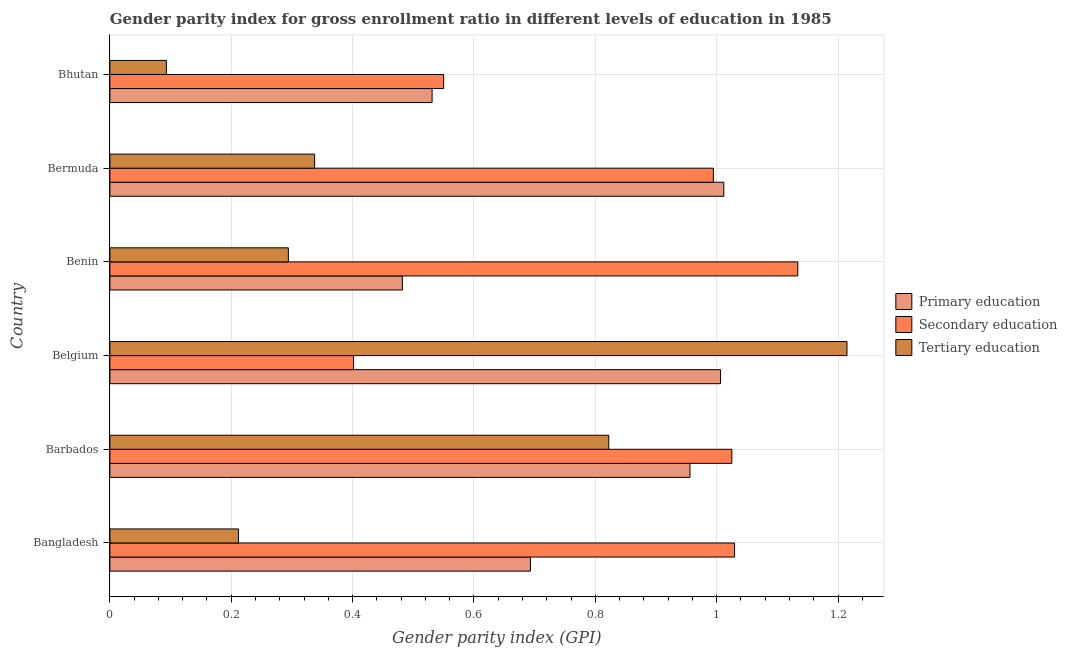Are the number of bars per tick equal to the number of legend labels?
Your answer should be very brief. Yes. Are the number of bars on each tick of the Y-axis equal?
Offer a terse response. Yes. How many bars are there on the 1st tick from the top?
Give a very brief answer. 3. How many bars are there on the 3rd tick from the bottom?
Your answer should be compact. 3. What is the label of the 1st group of bars from the top?
Offer a terse response. Bhutan. What is the gender parity index in tertiary education in Bhutan?
Ensure brevity in your answer.  0.09. Across all countries, what is the maximum gender parity index in primary education?
Your response must be concise. 1.01. Across all countries, what is the minimum gender parity index in primary education?
Your response must be concise. 0.48. In which country was the gender parity index in secondary education maximum?
Ensure brevity in your answer.  Benin. In which country was the gender parity index in tertiary education minimum?
Offer a very short reply. Bhutan. What is the total gender parity index in primary education in the graph?
Your answer should be very brief. 4.68. What is the difference between the gender parity index in tertiary education in Belgium and that in Benin?
Ensure brevity in your answer.  0.92. What is the difference between the gender parity index in tertiary education in Bangladesh and the gender parity index in secondary education in Bhutan?
Make the answer very short. -0.34. What is the average gender parity index in primary education per country?
Make the answer very short. 0.78. What is the difference between the gender parity index in secondary education and gender parity index in primary education in Bangladesh?
Ensure brevity in your answer.  0.34. What is the ratio of the gender parity index in secondary education in Bangladesh to that in Bhutan?
Provide a succinct answer. 1.87. Is the gender parity index in secondary education in Bangladesh less than that in Benin?
Give a very brief answer. Yes. Is the difference between the gender parity index in secondary education in Benin and Bermuda greater than the difference between the gender parity index in tertiary education in Benin and Bermuda?
Provide a succinct answer. Yes. What is the difference between the highest and the second highest gender parity index in tertiary education?
Your answer should be compact. 0.39. What is the difference between the highest and the lowest gender parity index in secondary education?
Make the answer very short. 0.73. In how many countries, is the gender parity index in primary education greater than the average gender parity index in primary education taken over all countries?
Your response must be concise. 3. What does the 2nd bar from the top in Bermuda represents?
Provide a short and direct response. Secondary education. What does the 3rd bar from the bottom in Bangladesh represents?
Keep it short and to the point. Tertiary education. Is it the case that in every country, the sum of the gender parity index in primary education and gender parity index in secondary education is greater than the gender parity index in tertiary education?
Give a very brief answer. Yes. How many bars are there?
Your response must be concise. 18. Are the values on the major ticks of X-axis written in scientific E-notation?
Your answer should be very brief. No. Does the graph contain any zero values?
Keep it short and to the point. No. What is the title of the graph?
Offer a terse response. Gender parity index for gross enrollment ratio in different levels of education in 1985. Does "Taxes on international trade" appear as one of the legend labels in the graph?
Give a very brief answer. No. What is the label or title of the X-axis?
Make the answer very short. Gender parity index (GPI). What is the label or title of the Y-axis?
Provide a succinct answer. Country. What is the Gender parity index (GPI) of Primary education in Bangladesh?
Provide a succinct answer. 0.69. What is the Gender parity index (GPI) in Secondary education in Bangladesh?
Your response must be concise. 1.03. What is the Gender parity index (GPI) in Tertiary education in Bangladesh?
Your answer should be compact. 0.21. What is the Gender parity index (GPI) of Primary education in Barbados?
Your answer should be very brief. 0.96. What is the Gender parity index (GPI) in Secondary education in Barbados?
Give a very brief answer. 1.02. What is the Gender parity index (GPI) of Tertiary education in Barbados?
Your answer should be very brief. 0.82. What is the Gender parity index (GPI) in Primary education in Belgium?
Offer a very short reply. 1.01. What is the Gender parity index (GPI) in Secondary education in Belgium?
Provide a succinct answer. 0.4. What is the Gender parity index (GPI) of Tertiary education in Belgium?
Offer a very short reply. 1.21. What is the Gender parity index (GPI) of Primary education in Benin?
Provide a short and direct response. 0.48. What is the Gender parity index (GPI) in Secondary education in Benin?
Your answer should be very brief. 1.13. What is the Gender parity index (GPI) in Tertiary education in Benin?
Provide a short and direct response. 0.29. What is the Gender parity index (GPI) in Primary education in Bermuda?
Your response must be concise. 1.01. What is the Gender parity index (GPI) in Secondary education in Bermuda?
Offer a terse response. 0.99. What is the Gender parity index (GPI) in Tertiary education in Bermuda?
Ensure brevity in your answer.  0.34. What is the Gender parity index (GPI) of Primary education in Bhutan?
Provide a short and direct response. 0.53. What is the Gender parity index (GPI) of Secondary education in Bhutan?
Provide a short and direct response. 0.55. What is the Gender parity index (GPI) in Tertiary education in Bhutan?
Offer a very short reply. 0.09. Across all countries, what is the maximum Gender parity index (GPI) in Primary education?
Offer a terse response. 1.01. Across all countries, what is the maximum Gender parity index (GPI) in Secondary education?
Your answer should be very brief. 1.13. Across all countries, what is the maximum Gender parity index (GPI) in Tertiary education?
Ensure brevity in your answer.  1.21. Across all countries, what is the minimum Gender parity index (GPI) of Primary education?
Give a very brief answer. 0.48. Across all countries, what is the minimum Gender parity index (GPI) in Secondary education?
Keep it short and to the point. 0.4. Across all countries, what is the minimum Gender parity index (GPI) in Tertiary education?
Give a very brief answer. 0.09. What is the total Gender parity index (GPI) of Primary education in the graph?
Keep it short and to the point. 4.68. What is the total Gender parity index (GPI) in Secondary education in the graph?
Offer a terse response. 5.13. What is the total Gender parity index (GPI) in Tertiary education in the graph?
Provide a succinct answer. 2.97. What is the difference between the Gender parity index (GPI) in Primary education in Bangladesh and that in Barbados?
Offer a very short reply. -0.26. What is the difference between the Gender parity index (GPI) in Secondary education in Bangladesh and that in Barbados?
Provide a succinct answer. 0. What is the difference between the Gender parity index (GPI) of Tertiary education in Bangladesh and that in Barbados?
Provide a succinct answer. -0.61. What is the difference between the Gender parity index (GPI) in Primary education in Bangladesh and that in Belgium?
Your answer should be very brief. -0.31. What is the difference between the Gender parity index (GPI) in Secondary education in Bangladesh and that in Belgium?
Ensure brevity in your answer.  0.63. What is the difference between the Gender parity index (GPI) of Tertiary education in Bangladesh and that in Belgium?
Your answer should be compact. -1. What is the difference between the Gender parity index (GPI) in Primary education in Bangladesh and that in Benin?
Make the answer very short. 0.21. What is the difference between the Gender parity index (GPI) in Secondary education in Bangladesh and that in Benin?
Offer a terse response. -0.1. What is the difference between the Gender parity index (GPI) of Tertiary education in Bangladesh and that in Benin?
Make the answer very short. -0.08. What is the difference between the Gender parity index (GPI) of Primary education in Bangladesh and that in Bermuda?
Provide a succinct answer. -0.32. What is the difference between the Gender parity index (GPI) in Secondary education in Bangladesh and that in Bermuda?
Provide a succinct answer. 0.03. What is the difference between the Gender parity index (GPI) in Tertiary education in Bangladesh and that in Bermuda?
Offer a very short reply. -0.13. What is the difference between the Gender parity index (GPI) of Primary education in Bangladesh and that in Bhutan?
Make the answer very short. 0.16. What is the difference between the Gender parity index (GPI) in Secondary education in Bangladesh and that in Bhutan?
Offer a terse response. 0.48. What is the difference between the Gender parity index (GPI) in Tertiary education in Bangladesh and that in Bhutan?
Keep it short and to the point. 0.12. What is the difference between the Gender parity index (GPI) of Primary education in Barbados and that in Belgium?
Make the answer very short. -0.05. What is the difference between the Gender parity index (GPI) of Secondary education in Barbados and that in Belgium?
Ensure brevity in your answer.  0.62. What is the difference between the Gender parity index (GPI) of Tertiary education in Barbados and that in Belgium?
Provide a succinct answer. -0.39. What is the difference between the Gender parity index (GPI) of Primary education in Barbados and that in Benin?
Give a very brief answer. 0.47. What is the difference between the Gender parity index (GPI) of Secondary education in Barbados and that in Benin?
Make the answer very short. -0.11. What is the difference between the Gender parity index (GPI) in Tertiary education in Barbados and that in Benin?
Provide a short and direct response. 0.53. What is the difference between the Gender parity index (GPI) of Primary education in Barbados and that in Bermuda?
Ensure brevity in your answer.  -0.06. What is the difference between the Gender parity index (GPI) in Secondary education in Barbados and that in Bermuda?
Offer a terse response. 0.03. What is the difference between the Gender parity index (GPI) of Tertiary education in Barbados and that in Bermuda?
Your response must be concise. 0.48. What is the difference between the Gender parity index (GPI) in Primary education in Barbados and that in Bhutan?
Make the answer very short. 0.42. What is the difference between the Gender parity index (GPI) in Secondary education in Barbados and that in Bhutan?
Offer a terse response. 0.47. What is the difference between the Gender parity index (GPI) of Tertiary education in Barbados and that in Bhutan?
Give a very brief answer. 0.73. What is the difference between the Gender parity index (GPI) in Primary education in Belgium and that in Benin?
Your answer should be compact. 0.52. What is the difference between the Gender parity index (GPI) of Secondary education in Belgium and that in Benin?
Ensure brevity in your answer.  -0.73. What is the difference between the Gender parity index (GPI) of Tertiary education in Belgium and that in Benin?
Offer a terse response. 0.92. What is the difference between the Gender parity index (GPI) of Primary education in Belgium and that in Bermuda?
Offer a very short reply. -0.01. What is the difference between the Gender parity index (GPI) in Secondary education in Belgium and that in Bermuda?
Your answer should be very brief. -0.59. What is the difference between the Gender parity index (GPI) in Tertiary education in Belgium and that in Bermuda?
Your answer should be very brief. 0.88. What is the difference between the Gender parity index (GPI) in Primary education in Belgium and that in Bhutan?
Provide a short and direct response. 0.48. What is the difference between the Gender parity index (GPI) of Secondary education in Belgium and that in Bhutan?
Offer a terse response. -0.15. What is the difference between the Gender parity index (GPI) of Tertiary education in Belgium and that in Bhutan?
Your response must be concise. 1.12. What is the difference between the Gender parity index (GPI) of Primary education in Benin and that in Bermuda?
Give a very brief answer. -0.53. What is the difference between the Gender parity index (GPI) in Secondary education in Benin and that in Bermuda?
Your answer should be compact. 0.14. What is the difference between the Gender parity index (GPI) of Tertiary education in Benin and that in Bermuda?
Offer a terse response. -0.04. What is the difference between the Gender parity index (GPI) of Primary education in Benin and that in Bhutan?
Your answer should be very brief. -0.05. What is the difference between the Gender parity index (GPI) in Secondary education in Benin and that in Bhutan?
Your answer should be compact. 0.58. What is the difference between the Gender parity index (GPI) in Tertiary education in Benin and that in Bhutan?
Your answer should be compact. 0.2. What is the difference between the Gender parity index (GPI) in Primary education in Bermuda and that in Bhutan?
Your response must be concise. 0.48. What is the difference between the Gender parity index (GPI) of Secondary education in Bermuda and that in Bhutan?
Offer a terse response. 0.44. What is the difference between the Gender parity index (GPI) in Tertiary education in Bermuda and that in Bhutan?
Offer a very short reply. 0.24. What is the difference between the Gender parity index (GPI) in Primary education in Bangladesh and the Gender parity index (GPI) in Secondary education in Barbados?
Provide a succinct answer. -0.33. What is the difference between the Gender parity index (GPI) of Primary education in Bangladesh and the Gender parity index (GPI) of Tertiary education in Barbados?
Your answer should be very brief. -0.13. What is the difference between the Gender parity index (GPI) of Secondary education in Bangladesh and the Gender parity index (GPI) of Tertiary education in Barbados?
Make the answer very short. 0.21. What is the difference between the Gender parity index (GPI) in Primary education in Bangladesh and the Gender parity index (GPI) in Secondary education in Belgium?
Your answer should be very brief. 0.29. What is the difference between the Gender parity index (GPI) in Primary education in Bangladesh and the Gender parity index (GPI) in Tertiary education in Belgium?
Give a very brief answer. -0.52. What is the difference between the Gender parity index (GPI) in Secondary education in Bangladesh and the Gender parity index (GPI) in Tertiary education in Belgium?
Your answer should be compact. -0.19. What is the difference between the Gender parity index (GPI) of Primary education in Bangladesh and the Gender parity index (GPI) of Secondary education in Benin?
Your answer should be compact. -0.44. What is the difference between the Gender parity index (GPI) in Primary education in Bangladesh and the Gender parity index (GPI) in Tertiary education in Benin?
Ensure brevity in your answer.  0.4. What is the difference between the Gender parity index (GPI) in Secondary education in Bangladesh and the Gender parity index (GPI) in Tertiary education in Benin?
Make the answer very short. 0.74. What is the difference between the Gender parity index (GPI) in Primary education in Bangladesh and the Gender parity index (GPI) in Secondary education in Bermuda?
Give a very brief answer. -0.3. What is the difference between the Gender parity index (GPI) of Primary education in Bangladesh and the Gender parity index (GPI) of Tertiary education in Bermuda?
Your answer should be very brief. 0.36. What is the difference between the Gender parity index (GPI) of Secondary education in Bangladesh and the Gender parity index (GPI) of Tertiary education in Bermuda?
Keep it short and to the point. 0.69. What is the difference between the Gender parity index (GPI) in Primary education in Bangladesh and the Gender parity index (GPI) in Secondary education in Bhutan?
Your answer should be compact. 0.14. What is the difference between the Gender parity index (GPI) of Secondary education in Bangladesh and the Gender parity index (GPI) of Tertiary education in Bhutan?
Offer a very short reply. 0.94. What is the difference between the Gender parity index (GPI) in Primary education in Barbados and the Gender parity index (GPI) in Secondary education in Belgium?
Your response must be concise. 0.55. What is the difference between the Gender parity index (GPI) in Primary education in Barbados and the Gender parity index (GPI) in Tertiary education in Belgium?
Give a very brief answer. -0.26. What is the difference between the Gender parity index (GPI) in Secondary education in Barbados and the Gender parity index (GPI) in Tertiary education in Belgium?
Offer a very short reply. -0.19. What is the difference between the Gender parity index (GPI) in Primary education in Barbados and the Gender parity index (GPI) in Secondary education in Benin?
Make the answer very short. -0.18. What is the difference between the Gender parity index (GPI) of Primary education in Barbados and the Gender parity index (GPI) of Tertiary education in Benin?
Provide a succinct answer. 0.66. What is the difference between the Gender parity index (GPI) in Secondary education in Barbados and the Gender parity index (GPI) in Tertiary education in Benin?
Ensure brevity in your answer.  0.73. What is the difference between the Gender parity index (GPI) of Primary education in Barbados and the Gender parity index (GPI) of Secondary education in Bermuda?
Give a very brief answer. -0.04. What is the difference between the Gender parity index (GPI) in Primary education in Barbados and the Gender parity index (GPI) in Tertiary education in Bermuda?
Your answer should be very brief. 0.62. What is the difference between the Gender parity index (GPI) of Secondary education in Barbados and the Gender parity index (GPI) of Tertiary education in Bermuda?
Offer a very short reply. 0.69. What is the difference between the Gender parity index (GPI) in Primary education in Barbados and the Gender parity index (GPI) in Secondary education in Bhutan?
Your answer should be compact. 0.41. What is the difference between the Gender parity index (GPI) of Primary education in Barbados and the Gender parity index (GPI) of Tertiary education in Bhutan?
Make the answer very short. 0.86. What is the difference between the Gender parity index (GPI) of Secondary education in Barbados and the Gender parity index (GPI) of Tertiary education in Bhutan?
Keep it short and to the point. 0.93. What is the difference between the Gender parity index (GPI) of Primary education in Belgium and the Gender parity index (GPI) of Secondary education in Benin?
Your response must be concise. -0.13. What is the difference between the Gender parity index (GPI) of Primary education in Belgium and the Gender parity index (GPI) of Tertiary education in Benin?
Your response must be concise. 0.71. What is the difference between the Gender parity index (GPI) in Secondary education in Belgium and the Gender parity index (GPI) in Tertiary education in Benin?
Your answer should be compact. 0.11. What is the difference between the Gender parity index (GPI) of Primary education in Belgium and the Gender parity index (GPI) of Secondary education in Bermuda?
Provide a short and direct response. 0.01. What is the difference between the Gender parity index (GPI) in Primary education in Belgium and the Gender parity index (GPI) in Tertiary education in Bermuda?
Your answer should be very brief. 0.67. What is the difference between the Gender parity index (GPI) of Secondary education in Belgium and the Gender parity index (GPI) of Tertiary education in Bermuda?
Your response must be concise. 0.06. What is the difference between the Gender parity index (GPI) of Primary education in Belgium and the Gender parity index (GPI) of Secondary education in Bhutan?
Offer a terse response. 0.46. What is the difference between the Gender parity index (GPI) in Primary education in Belgium and the Gender parity index (GPI) in Tertiary education in Bhutan?
Ensure brevity in your answer.  0.91. What is the difference between the Gender parity index (GPI) in Secondary education in Belgium and the Gender parity index (GPI) in Tertiary education in Bhutan?
Your answer should be very brief. 0.31. What is the difference between the Gender parity index (GPI) in Primary education in Benin and the Gender parity index (GPI) in Secondary education in Bermuda?
Your answer should be compact. -0.51. What is the difference between the Gender parity index (GPI) in Primary education in Benin and the Gender parity index (GPI) in Tertiary education in Bermuda?
Make the answer very short. 0.14. What is the difference between the Gender parity index (GPI) of Secondary education in Benin and the Gender parity index (GPI) of Tertiary education in Bermuda?
Offer a very short reply. 0.8. What is the difference between the Gender parity index (GPI) of Primary education in Benin and the Gender parity index (GPI) of Secondary education in Bhutan?
Ensure brevity in your answer.  -0.07. What is the difference between the Gender parity index (GPI) of Primary education in Benin and the Gender parity index (GPI) of Tertiary education in Bhutan?
Your response must be concise. 0.39. What is the difference between the Gender parity index (GPI) in Secondary education in Benin and the Gender parity index (GPI) in Tertiary education in Bhutan?
Keep it short and to the point. 1.04. What is the difference between the Gender parity index (GPI) of Primary education in Bermuda and the Gender parity index (GPI) of Secondary education in Bhutan?
Keep it short and to the point. 0.46. What is the difference between the Gender parity index (GPI) in Primary education in Bermuda and the Gender parity index (GPI) in Tertiary education in Bhutan?
Offer a terse response. 0.92. What is the difference between the Gender parity index (GPI) in Secondary education in Bermuda and the Gender parity index (GPI) in Tertiary education in Bhutan?
Your answer should be very brief. 0.9. What is the average Gender parity index (GPI) in Primary education per country?
Ensure brevity in your answer.  0.78. What is the average Gender parity index (GPI) of Secondary education per country?
Your answer should be very brief. 0.86. What is the average Gender parity index (GPI) of Tertiary education per country?
Make the answer very short. 0.5. What is the difference between the Gender parity index (GPI) in Primary education and Gender parity index (GPI) in Secondary education in Bangladesh?
Provide a succinct answer. -0.34. What is the difference between the Gender parity index (GPI) of Primary education and Gender parity index (GPI) of Tertiary education in Bangladesh?
Keep it short and to the point. 0.48. What is the difference between the Gender parity index (GPI) of Secondary education and Gender parity index (GPI) of Tertiary education in Bangladesh?
Your response must be concise. 0.82. What is the difference between the Gender parity index (GPI) in Primary education and Gender parity index (GPI) in Secondary education in Barbados?
Make the answer very short. -0.07. What is the difference between the Gender parity index (GPI) in Primary education and Gender parity index (GPI) in Tertiary education in Barbados?
Make the answer very short. 0.13. What is the difference between the Gender parity index (GPI) in Secondary education and Gender parity index (GPI) in Tertiary education in Barbados?
Give a very brief answer. 0.2. What is the difference between the Gender parity index (GPI) of Primary education and Gender parity index (GPI) of Secondary education in Belgium?
Make the answer very short. 0.6. What is the difference between the Gender parity index (GPI) of Primary education and Gender parity index (GPI) of Tertiary education in Belgium?
Provide a short and direct response. -0.21. What is the difference between the Gender parity index (GPI) of Secondary education and Gender parity index (GPI) of Tertiary education in Belgium?
Offer a very short reply. -0.81. What is the difference between the Gender parity index (GPI) in Primary education and Gender parity index (GPI) in Secondary education in Benin?
Offer a very short reply. -0.65. What is the difference between the Gender parity index (GPI) in Primary education and Gender parity index (GPI) in Tertiary education in Benin?
Make the answer very short. 0.19. What is the difference between the Gender parity index (GPI) in Secondary education and Gender parity index (GPI) in Tertiary education in Benin?
Your answer should be compact. 0.84. What is the difference between the Gender parity index (GPI) in Primary education and Gender parity index (GPI) in Secondary education in Bermuda?
Your answer should be compact. 0.02. What is the difference between the Gender parity index (GPI) in Primary education and Gender parity index (GPI) in Tertiary education in Bermuda?
Keep it short and to the point. 0.67. What is the difference between the Gender parity index (GPI) in Secondary education and Gender parity index (GPI) in Tertiary education in Bermuda?
Your answer should be compact. 0.66. What is the difference between the Gender parity index (GPI) in Primary education and Gender parity index (GPI) in Secondary education in Bhutan?
Provide a short and direct response. -0.02. What is the difference between the Gender parity index (GPI) of Primary education and Gender parity index (GPI) of Tertiary education in Bhutan?
Your response must be concise. 0.44. What is the difference between the Gender parity index (GPI) in Secondary education and Gender parity index (GPI) in Tertiary education in Bhutan?
Make the answer very short. 0.46. What is the ratio of the Gender parity index (GPI) of Primary education in Bangladesh to that in Barbados?
Provide a succinct answer. 0.72. What is the ratio of the Gender parity index (GPI) of Tertiary education in Bangladesh to that in Barbados?
Offer a terse response. 0.26. What is the ratio of the Gender parity index (GPI) of Primary education in Bangladesh to that in Belgium?
Your answer should be compact. 0.69. What is the ratio of the Gender parity index (GPI) in Secondary education in Bangladesh to that in Belgium?
Give a very brief answer. 2.56. What is the ratio of the Gender parity index (GPI) in Tertiary education in Bangladesh to that in Belgium?
Your response must be concise. 0.17. What is the ratio of the Gender parity index (GPI) of Primary education in Bangladesh to that in Benin?
Your answer should be very brief. 1.44. What is the ratio of the Gender parity index (GPI) of Secondary education in Bangladesh to that in Benin?
Provide a succinct answer. 0.91. What is the ratio of the Gender parity index (GPI) in Tertiary education in Bangladesh to that in Benin?
Your response must be concise. 0.72. What is the ratio of the Gender parity index (GPI) of Primary education in Bangladesh to that in Bermuda?
Your answer should be compact. 0.69. What is the ratio of the Gender parity index (GPI) in Secondary education in Bangladesh to that in Bermuda?
Give a very brief answer. 1.04. What is the ratio of the Gender parity index (GPI) of Tertiary education in Bangladesh to that in Bermuda?
Provide a short and direct response. 0.63. What is the ratio of the Gender parity index (GPI) of Primary education in Bangladesh to that in Bhutan?
Your response must be concise. 1.31. What is the ratio of the Gender parity index (GPI) of Secondary education in Bangladesh to that in Bhutan?
Provide a short and direct response. 1.87. What is the ratio of the Gender parity index (GPI) in Tertiary education in Bangladesh to that in Bhutan?
Offer a very short reply. 2.28. What is the ratio of the Gender parity index (GPI) in Primary education in Barbados to that in Belgium?
Provide a short and direct response. 0.95. What is the ratio of the Gender parity index (GPI) of Secondary education in Barbados to that in Belgium?
Provide a succinct answer. 2.55. What is the ratio of the Gender parity index (GPI) of Tertiary education in Barbados to that in Belgium?
Ensure brevity in your answer.  0.68. What is the ratio of the Gender parity index (GPI) of Primary education in Barbados to that in Benin?
Give a very brief answer. 1.98. What is the ratio of the Gender parity index (GPI) of Secondary education in Barbados to that in Benin?
Your response must be concise. 0.9. What is the ratio of the Gender parity index (GPI) in Tertiary education in Barbados to that in Benin?
Your answer should be compact. 2.8. What is the ratio of the Gender parity index (GPI) in Primary education in Barbados to that in Bermuda?
Offer a terse response. 0.94. What is the ratio of the Gender parity index (GPI) in Secondary education in Barbados to that in Bermuda?
Make the answer very short. 1.03. What is the ratio of the Gender parity index (GPI) of Tertiary education in Barbados to that in Bermuda?
Give a very brief answer. 2.44. What is the ratio of the Gender parity index (GPI) of Primary education in Barbados to that in Bhutan?
Make the answer very short. 1.8. What is the ratio of the Gender parity index (GPI) in Secondary education in Barbados to that in Bhutan?
Provide a short and direct response. 1.86. What is the ratio of the Gender parity index (GPI) of Tertiary education in Barbados to that in Bhutan?
Offer a very short reply. 8.83. What is the ratio of the Gender parity index (GPI) of Primary education in Belgium to that in Benin?
Ensure brevity in your answer.  2.09. What is the ratio of the Gender parity index (GPI) in Secondary education in Belgium to that in Benin?
Ensure brevity in your answer.  0.35. What is the ratio of the Gender parity index (GPI) of Tertiary education in Belgium to that in Benin?
Make the answer very short. 4.13. What is the ratio of the Gender parity index (GPI) of Secondary education in Belgium to that in Bermuda?
Provide a short and direct response. 0.4. What is the ratio of the Gender parity index (GPI) of Tertiary education in Belgium to that in Bermuda?
Provide a succinct answer. 3.6. What is the ratio of the Gender parity index (GPI) of Primary education in Belgium to that in Bhutan?
Keep it short and to the point. 1.9. What is the ratio of the Gender parity index (GPI) of Secondary education in Belgium to that in Bhutan?
Ensure brevity in your answer.  0.73. What is the ratio of the Gender parity index (GPI) in Tertiary education in Belgium to that in Bhutan?
Your answer should be compact. 13.05. What is the ratio of the Gender parity index (GPI) in Primary education in Benin to that in Bermuda?
Give a very brief answer. 0.48. What is the ratio of the Gender parity index (GPI) of Secondary education in Benin to that in Bermuda?
Offer a terse response. 1.14. What is the ratio of the Gender parity index (GPI) in Tertiary education in Benin to that in Bermuda?
Offer a very short reply. 0.87. What is the ratio of the Gender parity index (GPI) in Primary education in Benin to that in Bhutan?
Offer a terse response. 0.91. What is the ratio of the Gender parity index (GPI) of Secondary education in Benin to that in Bhutan?
Give a very brief answer. 2.06. What is the ratio of the Gender parity index (GPI) in Tertiary education in Benin to that in Bhutan?
Make the answer very short. 3.16. What is the ratio of the Gender parity index (GPI) of Primary education in Bermuda to that in Bhutan?
Ensure brevity in your answer.  1.91. What is the ratio of the Gender parity index (GPI) in Secondary education in Bermuda to that in Bhutan?
Provide a succinct answer. 1.81. What is the ratio of the Gender parity index (GPI) of Tertiary education in Bermuda to that in Bhutan?
Offer a terse response. 3.62. What is the difference between the highest and the second highest Gender parity index (GPI) in Primary education?
Your response must be concise. 0.01. What is the difference between the highest and the second highest Gender parity index (GPI) in Secondary education?
Provide a succinct answer. 0.1. What is the difference between the highest and the second highest Gender parity index (GPI) in Tertiary education?
Ensure brevity in your answer.  0.39. What is the difference between the highest and the lowest Gender parity index (GPI) in Primary education?
Your answer should be very brief. 0.53. What is the difference between the highest and the lowest Gender parity index (GPI) of Secondary education?
Offer a very short reply. 0.73. What is the difference between the highest and the lowest Gender parity index (GPI) of Tertiary education?
Your response must be concise. 1.12. 